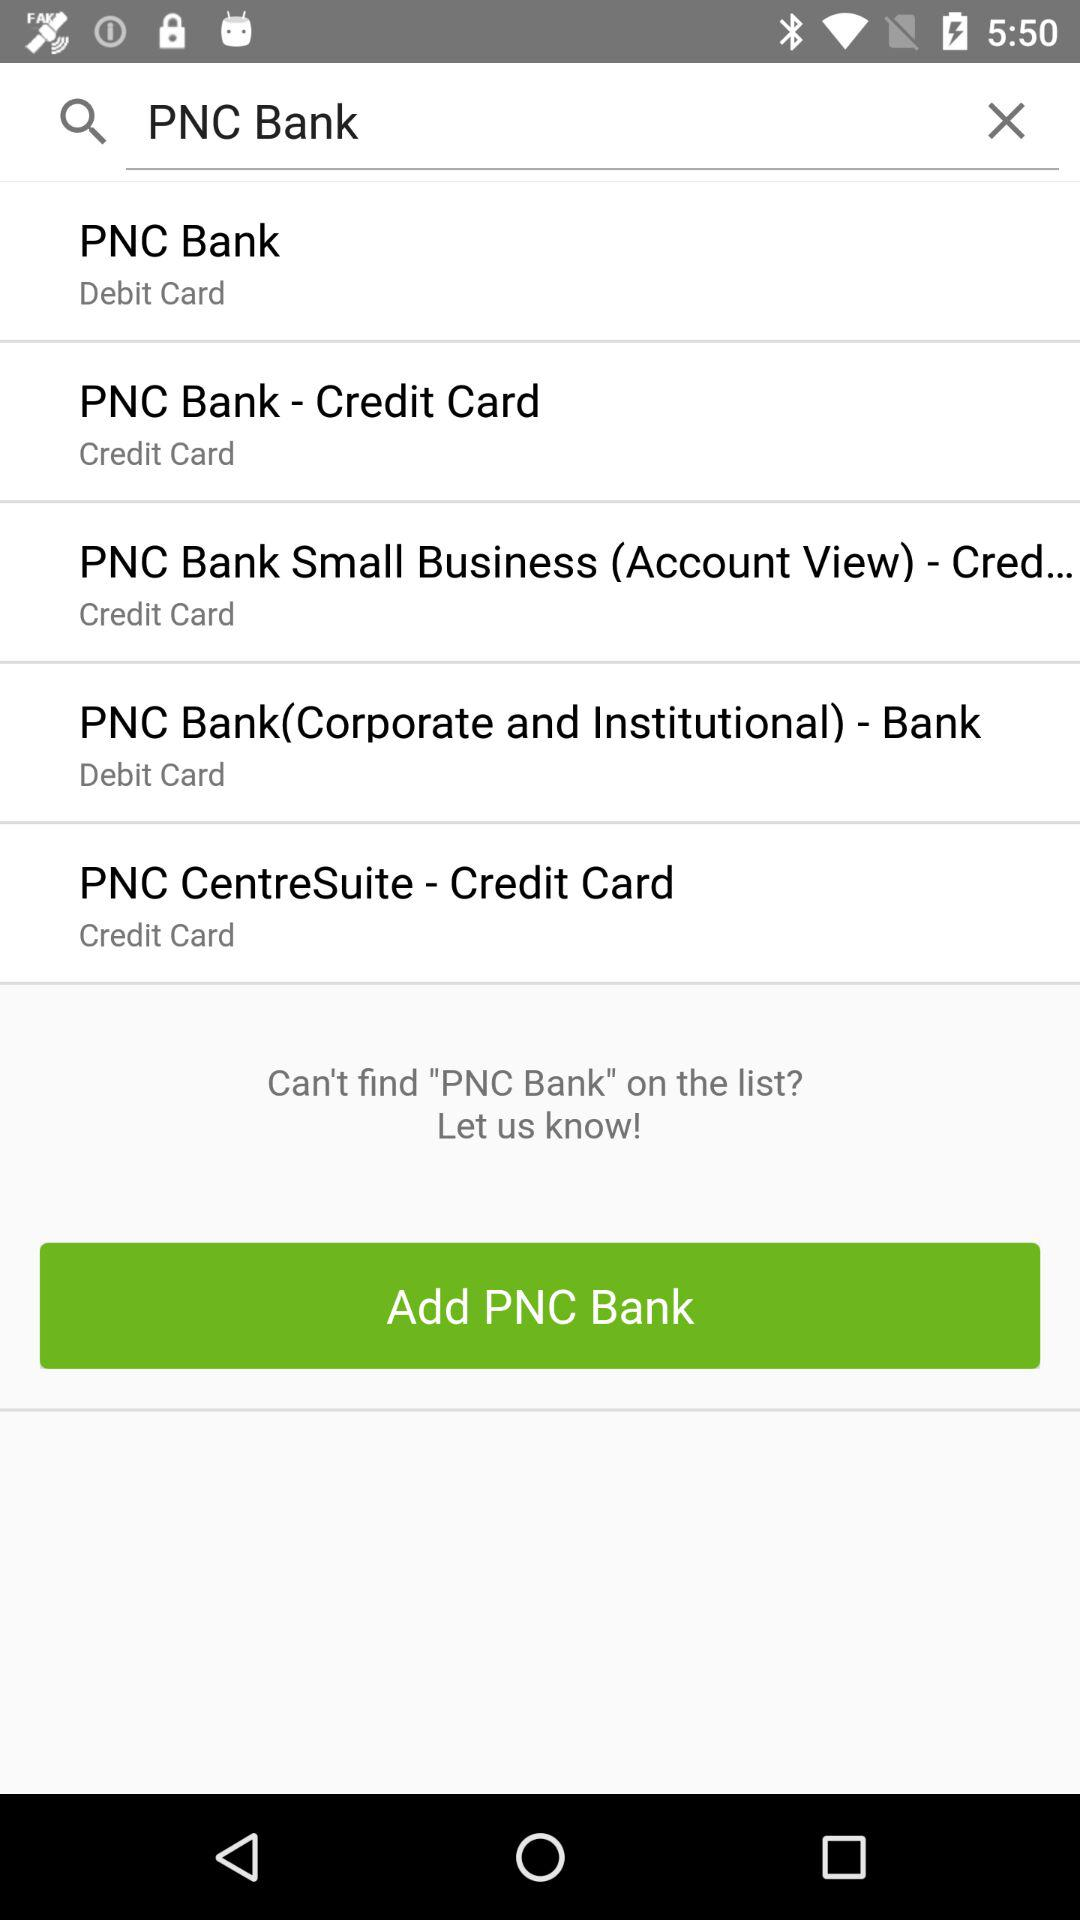How much money is available on the card?
When the provided information is insufficient, respond with <no answer>. <no answer> 